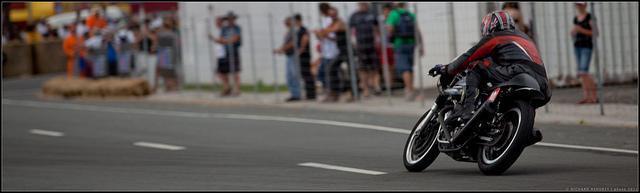How many bike tires are in the photo?
Give a very brief answer. 2. How many people are there?
Give a very brief answer. 2. 